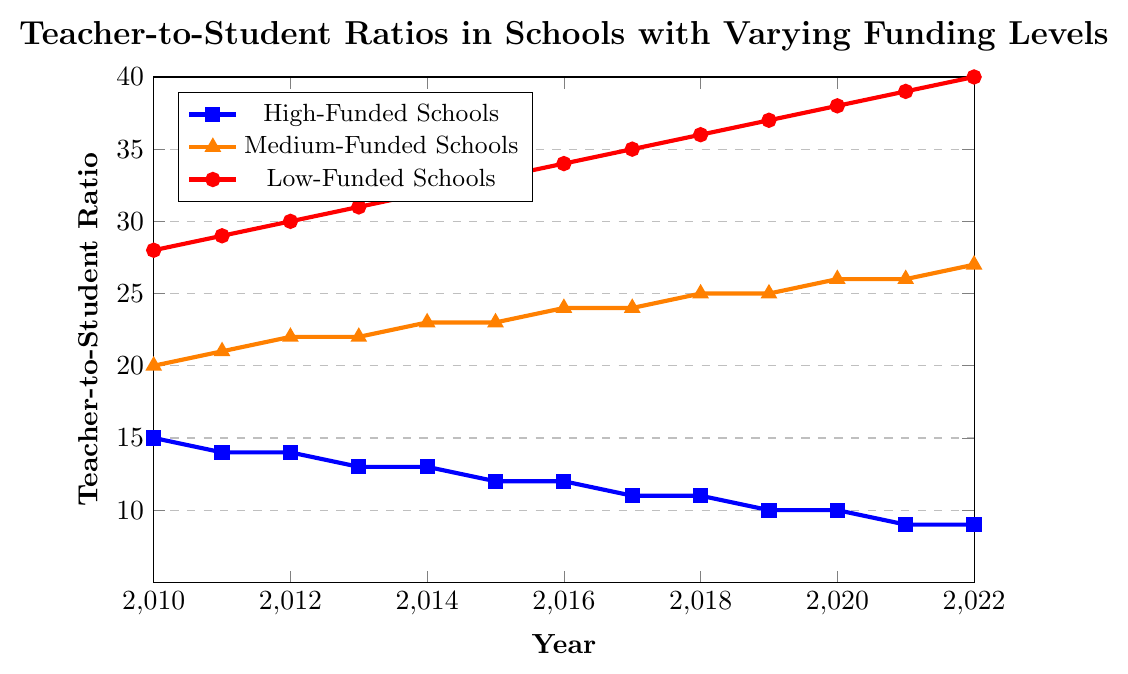What is the teacher-to-student ratio for high-funded schools in 2013? Locate the data point for high-funded schools in 2013 on the plot. The teacher-to-student ratio indicated by the blue line is 1:13.
Answer: 1:13 Comparing high-funded and low-funded schools, which had a lower teacher-to-student ratio in 2019? Find the teacher-to-student ratios for both high-funded and low-funded schools in 2019. High-funded schools have a ratio of 1:10 and low-funded schools have a ratio of 1:37. High-funded schools have the lower ratio.
Answer: high-funded schools What trend can be observed in the teacher-to-student ratio for medium-funded schools from 2010 to 2022? Follow the orange line for medium-funded schools from 2010 to 2022. The ratio shows an increasing trend from 1:20 in 2010 to 1:27 in 2022.
Answer: Increasing trend In which year did low-funded schools first surpass a teacher-to-student ratio of 1:35? Track the red line for low-funded schools and identify the first year the ratio exceeds 1:35, which happened in 2017.
Answer: 2017 What was the difference in teacher-to-student ratios between high-funded and low-funded schools in 2020? Identify the ratios for both high-funded (1:10) and low-funded (1:38) schools in 2020. Subtract the high-funded ratio from the low-funded ratio: 38 - 10 = 28.
Answer: 28 How many years did it take for the high-funded schools to improve from a ratio of 1:15 to 1:9? Locate the years when the high-funded schools had ratios of 1:15 (2010) and 1:9 (2021). Subtract 2010 from 2021 to find the duration: 2021 - 2010 = 11 years.
Answer: 11 years Which group had the steepest increase in teacher-to-student ratio from 2010 to 2022? Compare the slopes of the trend lines for high-funded, medium-funded, and low-funded schools. The red line for low-funded schools increases from 1:28 to 1:40, the steepest increase among the three groups.
Answer: low-funded schools What is the average teacher-to-student ratio for high-funded schools over the period from 2010 to 2022? Add up the ratios for high-funded schools from 2010 to 2022: (15 + 14 + 14 + 13 + 13 + 12 + 12 + 11 + 11 + 10 + 10 + 9 + 9) = 153. Divide by the number of years, 13: 153 / 13 ≈ 11.77.
Answer: 11.77 